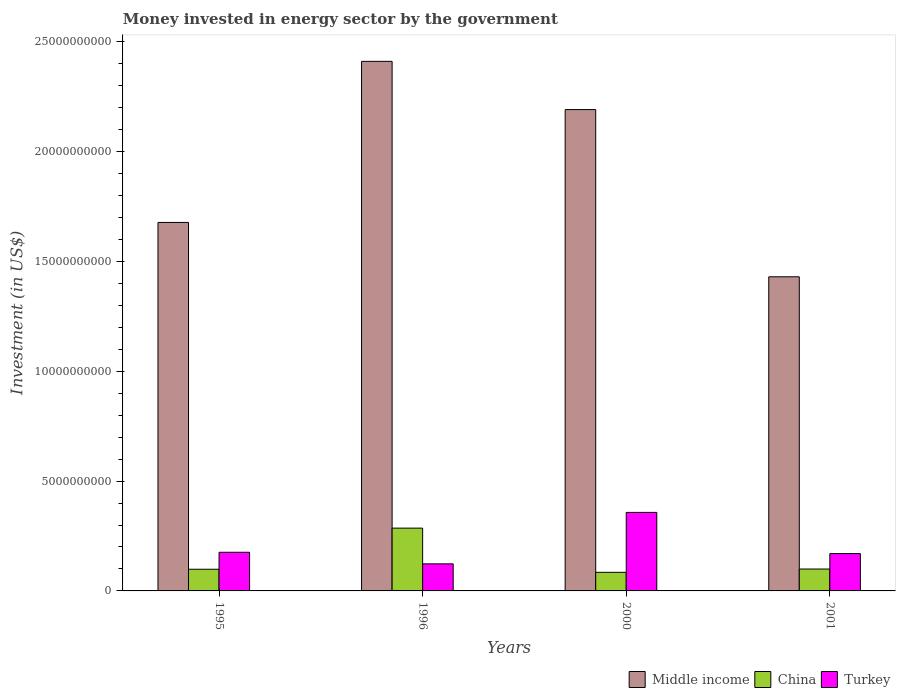How many different coloured bars are there?
Your answer should be compact. 3. How many groups of bars are there?
Keep it short and to the point. 4. Are the number of bars on each tick of the X-axis equal?
Make the answer very short. Yes. How many bars are there on the 3rd tick from the left?
Provide a succinct answer. 3. What is the label of the 4th group of bars from the left?
Make the answer very short. 2001. In how many cases, is the number of bars for a given year not equal to the number of legend labels?
Offer a very short reply. 0. What is the money spent in energy sector in Turkey in 1995?
Provide a succinct answer. 1.76e+09. Across all years, what is the maximum money spent in energy sector in China?
Provide a succinct answer. 2.86e+09. Across all years, what is the minimum money spent in energy sector in Turkey?
Your answer should be very brief. 1.23e+09. In which year was the money spent in energy sector in Middle income maximum?
Give a very brief answer. 1996. What is the total money spent in energy sector in Turkey in the graph?
Your answer should be compact. 8.27e+09. What is the difference between the money spent in energy sector in Turkey in 1995 and that in 2001?
Offer a terse response. 6.00e+07. What is the difference between the money spent in energy sector in Middle income in 1996 and the money spent in energy sector in Turkey in 1995?
Give a very brief answer. 2.24e+1. What is the average money spent in energy sector in Turkey per year?
Keep it short and to the point. 2.07e+09. In the year 2000, what is the difference between the money spent in energy sector in Middle income and money spent in energy sector in Turkey?
Your answer should be compact. 1.83e+1. In how many years, is the money spent in energy sector in China greater than 11000000000 US$?
Your response must be concise. 0. What is the ratio of the money spent in energy sector in China in 2000 to that in 2001?
Ensure brevity in your answer.  0.85. Is the money spent in energy sector in Turkey in 2000 less than that in 2001?
Offer a very short reply. No. What is the difference between the highest and the second highest money spent in energy sector in Turkey?
Give a very brief answer. 1.82e+09. What is the difference between the highest and the lowest money spent in energy sector in Turkey?
Your response must be concise. 2.34e+09. Is it the case that in every year, the sum of the money spent in energy sector in Middle income and money spent in energy sector in Turkey is greater than the money spent in energy sector in China?
Make the answer very short. Yes. What is the difference between two consecutive major ticks on the Y-axis?
Make the answer very short. 5.00e+09. Are the values on the major ticks of Y-axis written in scientific E-notation?
Provide a succinct answer. No. What is the title of the graph?
Give a very brief answer. Money invested in energy sector by the government. What is the label or title of the X-axis?
Provide a succinct answer. Years. What is the label or title of the Y-axis?
Offer a very short reply. Investment (in US$). What is the Investment (in US$) in Middle income in 1995?
Provide a succinct answer. 1.68e+1. What is the Investment (in US$) in China in 1995?
Your response must be concise. 9.87e+08. What is the Investment (in US$) in Turkey in 1995?
Make the answer very short. 1.76e+09. What is the Investment (in US$) in Middle income in 1996?
Keep it short and to the point. 2.41e+1. What is the Investment (in US$) in China in 1996?
Your answer should be compact. 2.86e+09. What is the Investment (in US$) of Turkey in 1996?
Keep it short and to the point. 1.23e+09. What is the Investment (in US$) of Middle income in 2000?
Give a very brief answer. 2.19e+1. What is the Investment (in US$) of China in 2000?
Your answer should be compact. 8.47e+08. What is the Investment (in US$) of Turkey in 2000?
Give a very brief answer. 3.58e+09. What is the Investment (in US$) of Middle income in 2001?
Your answer should be very brief. 1.43e+1. What is the Investment (in US$) of China in 2001?
Provide a succinct answer. 9.97e+08. What is the Investment (in US$) of Turkey in 2001?
Provide a succinct answer. 1.70e+09. Across all years, what is the maximum Investment (in US$) in Middle income?
Provide a succinct answer. 2.41e+1. Across all years, what is the maximum Investment (in US$) in China?
Keep it short and to the point. 2.86e+09. Across all years, what is the maximum Investment (in US$) of Turkey?
Give a very brief answer. 3.58e+09. Across all years, what is the minimum Investment (in US$) of Middle income?
Provide a short and direct response. 1.43e+1. Across all years, what is the minimum Investment (in US$) of China?
Provide a succinct answer. 8.47e+08. Across all years, what is the minimum Investment (in US$) of Turkey?
Offer a very short reply. 1.23e+09. What is the total Investment (in US$) in Middle income in the graph?
Provide a short and direct response. 7.71e+1. What is the total Investment (in US$) of China in the graph?
Offer a very short reply. 5.69e+09. What is the total Investment (in US$) in Turkey in the graph?
Provide a short and direct response. 8.27e+09. What is the difference between the Investment (in US$) of Middle income in 1995 and that in 1996?
Give a very brief answer. -7.33e+09. What is the difference between the Investment (in US$) of China in 1995 and that in 1996?
Make the answer very short. -1.87e+09. What is the difference between the Investment (in US$) in Turkey in 1995 and that in 1996?
Provide a succinct answer. 5.28e+08. What is the difference between the Investment (in US$) in Middle income in 1995 and that in 2000?
Provide a short and direct response. -5.14e+09. What is the difference between the Investment (in US$) of China in 1995 and that in 2000?
Your answer should be very brief. 1.41e+08. What is the difference between the Investment (in US$) in Turkey in 1995 and that in 2000?
Your answer should be very brief. -1.82e+09. What is the difference between the Investment (in US$) in Middle income in 1995 and that in 2001?
Your response must be concise. 2.47e+09. What is the difference between the Investment (in US$) in China in 1995 and that in 2001?
Your answer should be compact. -9.76e+06. What is the difference between the Investment (in US$) of Turkey in 1995 and that in 2001?
Offer a terse response. 6.00e+07. What is the difference between the Investment (in US$) of Middle income in 1996 and that in 2000?
Offer a terse response. 2.20e+09. What is the difference between the Investment (in US$) in China in 1996 and that in 2000?
Keep it short and to the point. 2.01e+09. What is the difference between the Investment (in US$) in Turkey in 1996 and that in 2000?
Your response must be concise. -2.34e+09. What is the difference between the Investment (in US$) of Middle income in 1996 and that in 2001?
Offer a terse response. 9.81e+09. What is the difference between the Investment (in US$) of China in 1996 and that in 2001?
Your answer should be compact. 1.86e+09. What is the difference between the Investment (in US$) of Turkey in 1996 and that in 2001?
Make the answer very short. -4.68e+08. What is the difference between the Investment (in US$) of Middle income in 2000 and that in 2001?
Provide a short and direct response. 7.61e+09. What is the difference between the Investment (in US$) of China in 2000 and that in 2001?
Give a very brief answer. -1.50e+08. What is the difference between the Investment (in US$) of Turkey in 2000 and that in 2001?
Offer a terse response. 1.88e+09. What is the difference between the Investment (in US$) of Middle income in 1995 and the Investment (in US$) of China in 1996?
Offer a very short reply. 1.39e+1. What is the difference between the Investment (in US$) in Middle income in 1995 and the Investment (in US$) in Turkey in 1996?
Keep it short and to the point. 1.55e+1. What is the difference between the Investment (in US$) of China in 1995 and the Investment (in US$) of Turkey in 1996?
Give a very brief answer. -2.45e+08. What is the difference between the Investment (in US$) in Middle income in 1995 and the Investment (in US$) in China in 2000?
Your answer should be compact. 1.59e+1. What is the difference between the Investment (in US$) in Middle income in 1995 and the Investment (in US$) in Turkey in 2000?
Keep it short and to the point. 1.32e+1. What is the difference between the Investment (in US$) in China in 1995 and the Investment (in US$) in Turkey in 2000?
Ensure brevity in your answer.  -2.59e+09. What is the difference between the Investment (in US$) in Middle income in 1995 and the Investment (in US$) in China in 2001?
Provide a succinct answer. 1.58e+1. What is the difference between the Investment (in US$) of Middle income in 1995 and the Investment (in US$) of Turkey in 2001?
Your answer should be compact. 1.51e+1. What is the difference between the Investment (in US$) of China in 1995 and the Investment (in US$) of Turkey in 2001?
Give a very brief answer. -7.13e+08. What is the difference between the Investment (in US$) in Middle income in 1996 and the Investment (in US$) in China in 2000?
Provide a short and direct response. 2.33e+1. What is the difference between the Investment (in US$) in Middle income in 1996 and the Investment (in US$) in Turkey in 2000?
Provide a succinct answer. 2.05e+1. What is the difference between the Investment (in US$) in China in 1996 and the Investment (in US$) in Turkey in 2000?
Provide a succinct answer. -7.16e+08. What is the difference between the Investment (in US$) in Middle income in 1996 and the Investment (in US$) in China in 2001?
Give a very brief answer. 2.31e+1. What is the difference between the Investment (in US$) in Middle income in 1996 and the Investment (in US$) in Turkey in 2001?
Keep it short and to the point. 2.24e+1. What is the difference between the Investment (in US$) of China in 1996 and the Investment (in US$) of Turkey in 2001?
Your response must be concise. 1.16e+09. What is the difference between the Investment (in US$) of Middle income in 2000 and the Investment (in US$) of China in 2001?
Offer a terse response. 2.09e+1. What is the difference between the Investment (in US$) in Middle income in 2000 and the Investment (in US$) in Turkey in 2001?
Provide a succinct answer. 2.02e+1. What is the difference between the Investment (in US$) in China in 2000 and the Investment (in US$) in Turkey in 2001?
Offer a terse response. -8.53e+08. What is the average Investment (in US$) of Middle income per year?
Keep it short and to the point. 1.93e+1. What is the average Investment (in US$) of China per year?
Your answer should be compact. 1.42e+09. What is the average Investment (in US$) of Turkey per year?
Give a very brief answer. 2.07e+09. In the year 1995, what is the difference between the Investment (in US$) of Middle income and Investment (in US$) of China?
Provide a succinct answer. 1.58e+1. In the year 1995, what is the difference between the Investment (in US$) of Middle income and Investment (in US$) of Turkey?
Offer a terse response. 1.50e+1. In the year 1995, what is the difference between the Investment (in US$) of China and Investment (in US$) of Turkey?
Provide a short and direct response. -7.73e+08. In the year 1996, what is the difference between the Investment (in US$) in Middle income and Investment (in US$) in China?
Your answer should be very brief. 2.13e+1. In the year 1996, what is the difference between the Investment (in US$) of Middle income and Investment (in US$) of Turkey?
Ensure brevity in your answer.  2.29e+1. In the year 1996, what is the difference between the Investment (in US$) in China and Investment (in US$) in Turkey?
Offer a very short reply. 1.63e+09. In the year 2000, what is the difference between the Investment (in US$) of Middle income and Investment (in US$) of China?
Your response must be concise. 2.11e+1. In the year 2000, what is the difference between the Investment (in US$) of Middle income and Investment (in US$) of Turkey?
Keep it short and to the point. 1.83e+1. In the year 2000, what is the difference between the Investment (in US$) of China and Investment (in US$) of Turkey?
Provide a short and direct response. -2.73e+09. In the year 2001, what is the difference between the Investment (in US$) in Middle income and Investment (in US$) in China?
Your answer should be compact. 1.33e+1. In the year 2001, what is the difference between the Investment (in US$) of Middle income and Investment (in US$) of Turkey?
Give a very brief answer. 1.26e+1. In the year 2001, what is the difference between the Investment (in US$) of China and Investment (in US$) of Turkey?
Your response must be concise. -7.03e+08. What is the ratio of the Investment (in US$) in Middle income in 1995 to that in 1996?
Your response must be concise. 0.7. What is the ratio of the Investment (in US$) in China in 1995 to that in 1996?
Your answer should be very brief. 0.35. What is the ratio of the Investment (in US$) in Turkey in 1995 to that in 1996?
Keep it short and to the point. 1.43. What is the ratio of the Investment (in US$) of Middle income in 1995 to that in 2000?
Provide a succinct answer. 0.77. What is the ratio of the Investment (in US$) of China in 1995 to that in 2000?
Keep it short and to the point. 1.17. What is the ratio of the Investment (in US$) in Turkey in 1995 to that in 2000?
Offer a terse response. 0.49. What is the ratio of the Investment (in US$) in Middle income in 1995 to that in 2001?
Provide a succinct answer. 1.17. What is the ratio of the Investment (in US$) of China in 1995 to that in 2001?
Ensure brevity in your answer.  0.99. What is the ratio of the Investment (in US$) of Turkey in 1995 to that in 2001?
Provide a short and direct response. 1.04. What is the ratio of the Investment (in US$) of Middle income in 1996 to that in 2000?
Offer a terse response. 1.1. What is the ratio of the Investment (in US$) of China in 1996 to that in 2000?
Give a very brief answer. 3.38. What is the ratio of the Investment (in US$) of Turkey in 1996 to that in 2000?
Provide a short and direct response. 0.34. What is the ratio of the Investment (in US$) in Middle income in 1996 to that in 2001?
Give a very brief answer. 1.69. What is the ratio of the Investment (in US$) of China in 1996 to that in 2001?
Offer a very short reply. 2.87. What is the ratio of the Investment (in US$) in Turkey in 1996 to that in 2001?
Keep it short and to the point. 0.72. What is the ratio of the Investment (in US$) of Middle income in 2000 to that in 2001?
Keep it short and to the point. 1.53. What is the ratio of the Investment (in US$) of China in 2000 to that in 2001?
Your response must be concise. 0.85. What is the ratio of the Investment (in US$) of Turkey in 2000 to that in 2001?
Ensure brevity in your answer.  2.1. What is the difference between the highest and the second highest Investment (in US$) of Middle income?
Offer a very short reply. 2.20e+09. What is the difference between the highest and the second highest Investment (in US$) of China?
Ensure brevity in your answer.  1.86e+09. What is the difference between the highest and the second highest Investment (in US$) of Turkey?
Make the answer very short. 1.82e+09. What is the difference between the highest and the lowest Investment (in US$) of Middle income?
Provide a short and direct response. 9.81e+09. What is the difference between the highest and the lowest Investment (in US$) of China?
Provide a short and direct response. 2.01e+09. What is the difference between the highest and the lowest Investment (in US$) in Turkey?
Your answer should be compact. 2.34e+09. 